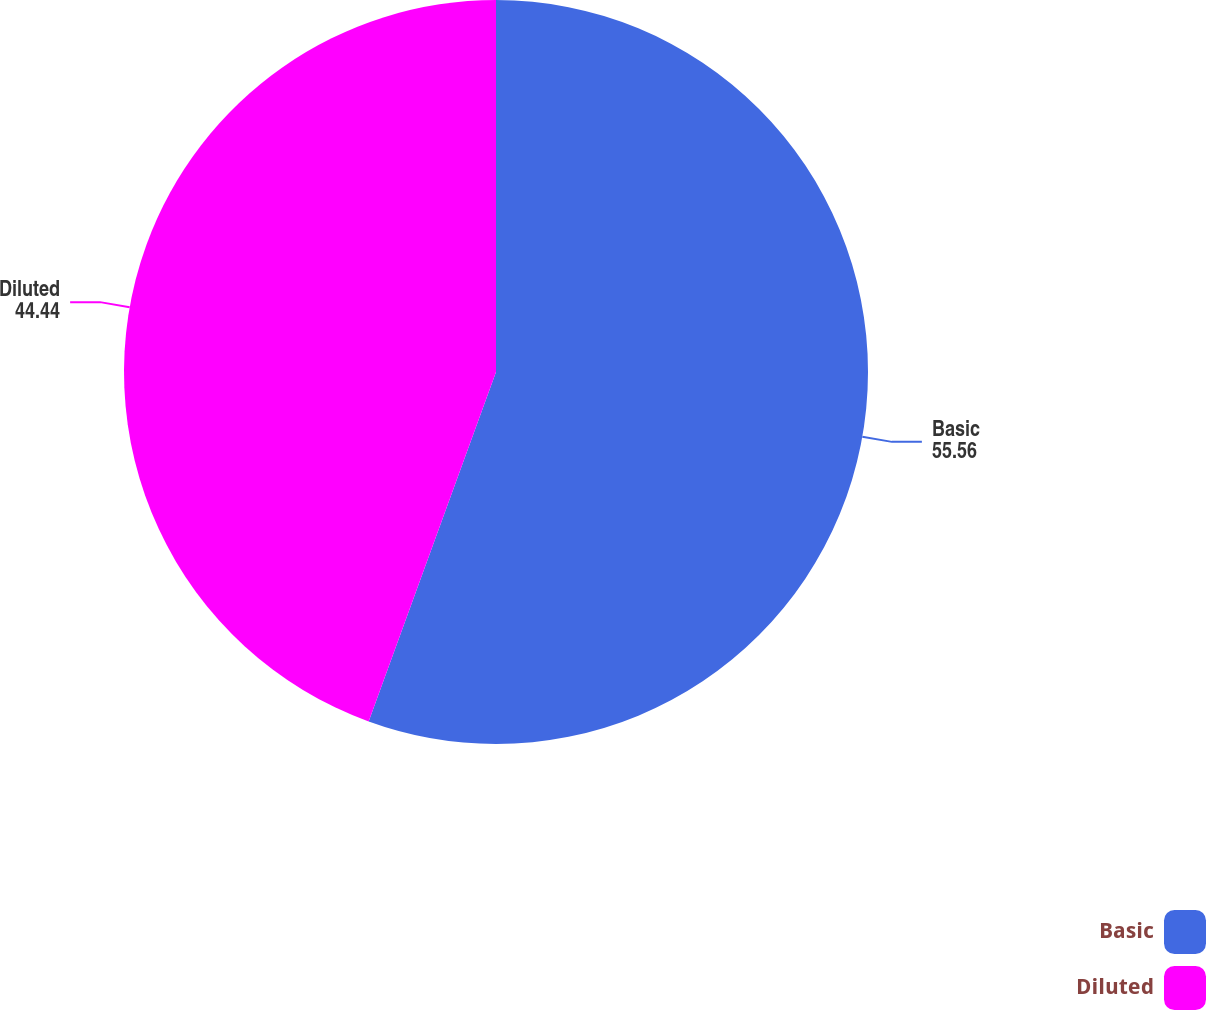<chart> <loc_0><loc_0><loc_500><loc_500><pie_chart><fcel>Basic<fcel>Diluted<nl><fcel>55.56%<fcel>44.44%<nl></chart> 